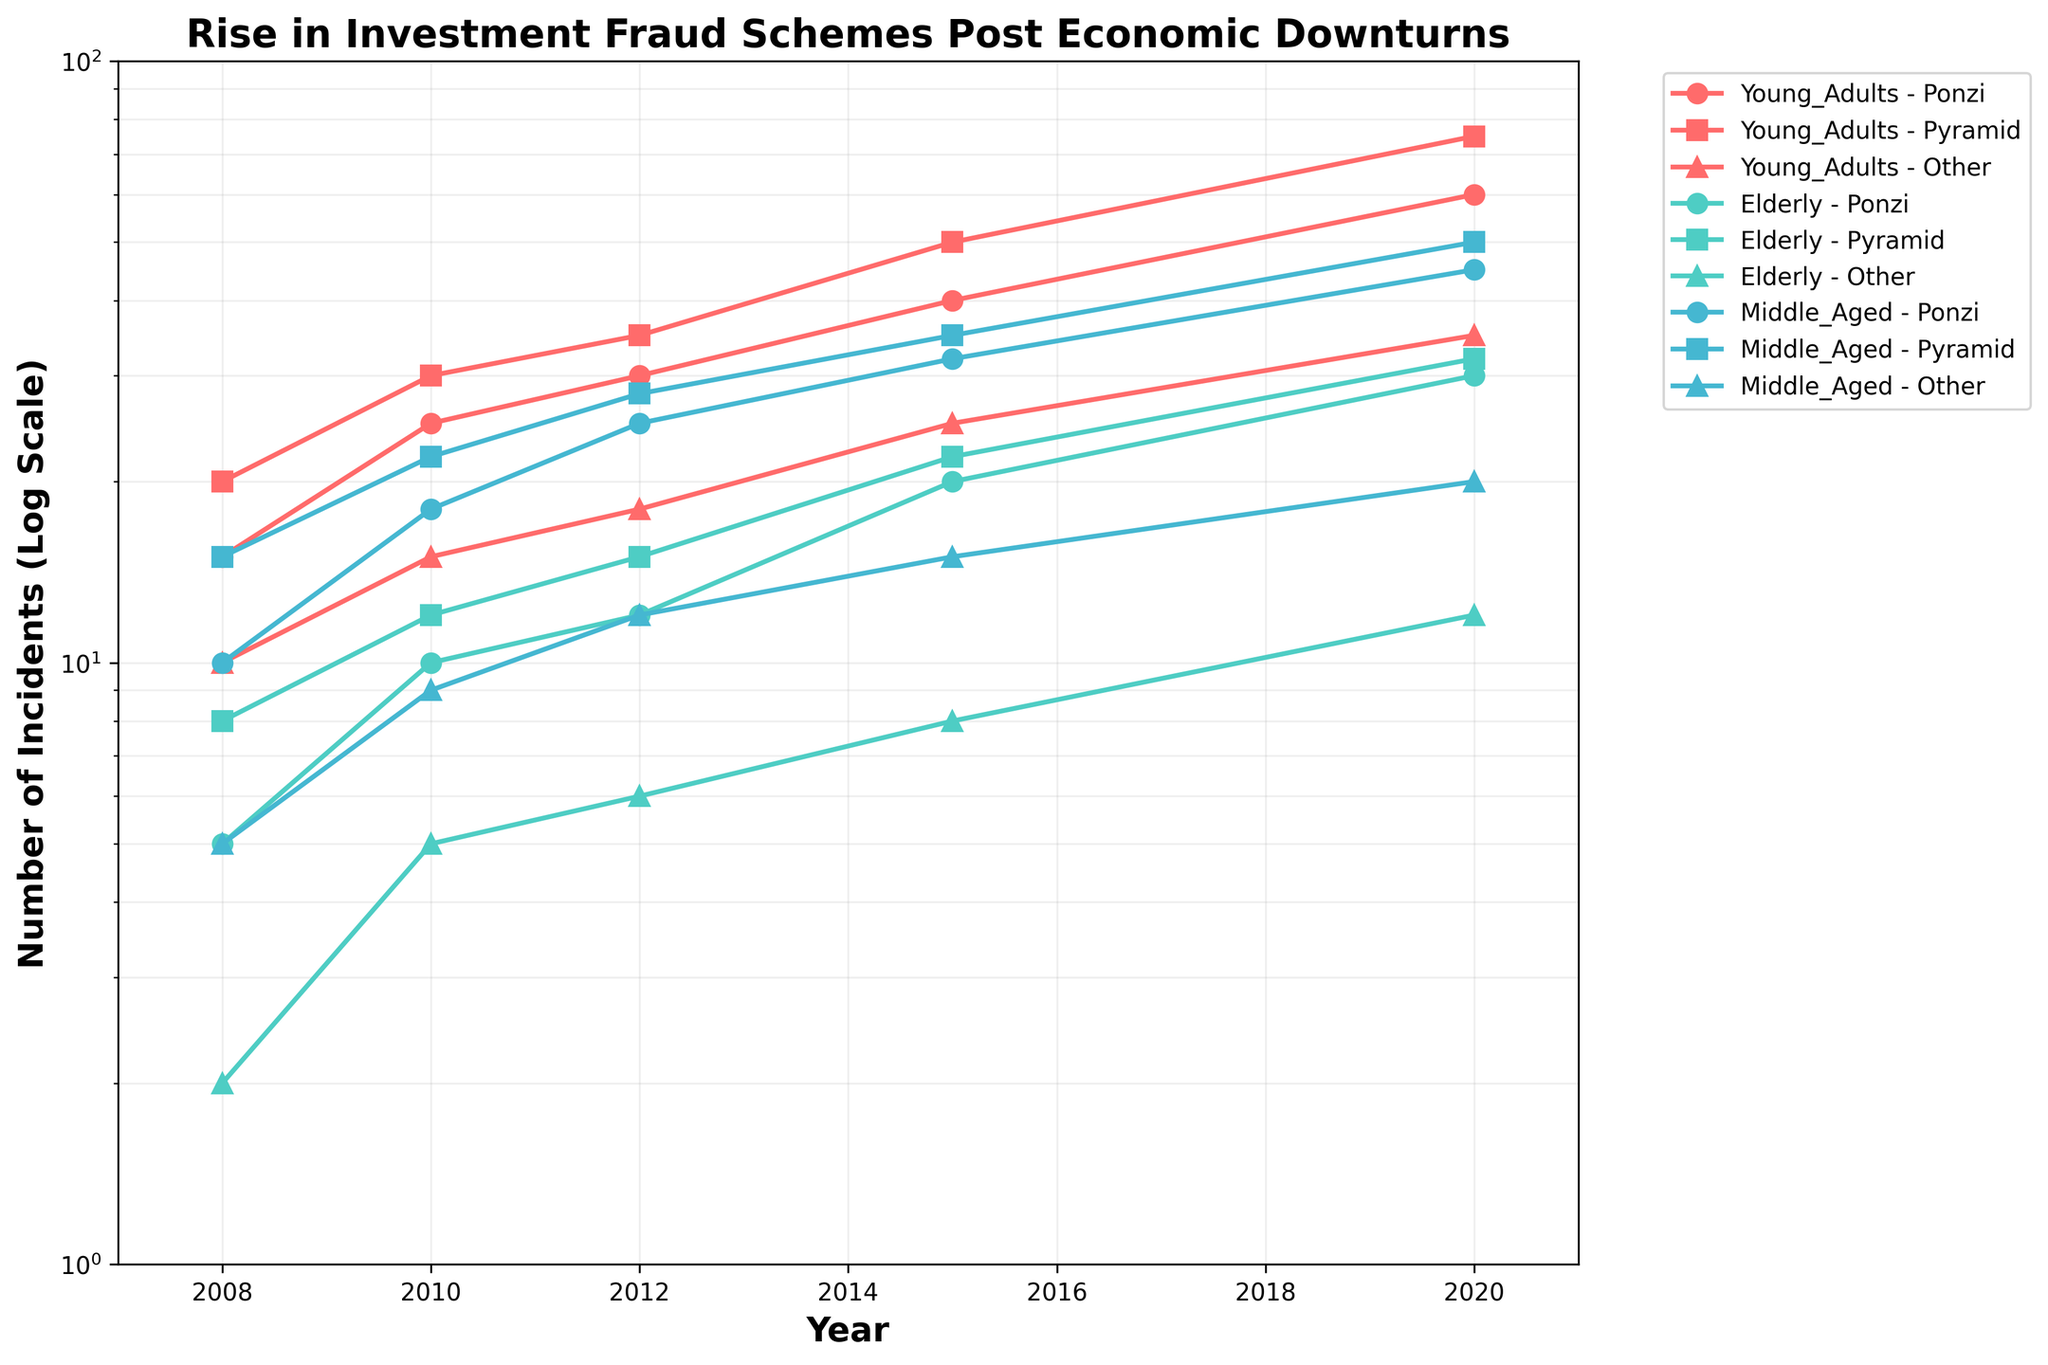What is the title of the plot? The title of the plot is displayed at the top center of the figure, providing an overview of the subject matter of the plot.
Answer: Rise in Investment Fraud Schemes Post Economic Downturns What are the colors used to represent the different demographic groups? The demographic groups are represented by distinct colors: Young Adults in red, Elderly in green, and Middle Aged in blue.
Answer: Red, Green, Blue Which demographic and type of scheme had the highest number of incidents in 2020? To answer this, look at the 2020 data points and identify which line reaches the highest point on the vertical axis for that year. The highest number is 75, corresponding to "Young Adults - Pyramid."
Answer: Young Adults - Pyramid What is the range of years displayed on the x-axis? The x-axis starts at the leftmost point and ends at the rightmost point, typically marked with the first and last years in the data range.
Answer: 2007 to 2021 How many incidents of Ponzi schemes were reported for the Elderly demographic in 2015? Locate the point in 2015 within the Elderly demographic line for Ponzi schemes and read the corresponding value.
Answer: 20 Which demographic saw the greatest increase in incidents of Ponzi schemes from 2008 to 2020? Calculate the difference between the 2020 and 2008 data points for each demographic group with respect to Ponzi schemes. Compare the differences to find the greatest increase. Young Adults increased by 60 - 15 = 45, Elderly by 30 - 5 = 25, and Middle Aged by 45 - 10 = 35. The greatest increase is in Young Adults.
Answer: Young Adults For the Middle_Aged demographic, how did the number of pyramid scheme incidents change from 2008 to 2010? Compare the number of incidents in 2008 and 2010 for the Middle_Aged demographic under Pyramid schemes. In 2008, it was 15, and in 2010, it was 22, so it increased by 7.
Answer: Increased by 7 Which type of scheme consistently had the lowest number of incidents across all demographics from 2008 to 2020? Observe the lines corresponding to each type of scheme across all demographics and note the values. "Other" schemes have consistently lower values compared to Ponzi and Pyramid schemes.
Answer: Other What is the trend in the number of incidents for Young Adults in Pyramid schemes between 2008 and 2020? Examine the line plot for Young Adults under Pyramid schemes from 2008 to 2020. The number of incidents steadily increases over this period.
Answer: Steady increase Compare the number of incidents for Ponzi schemes in 2012 between the Elderly and Middle_Aged demographics. Locate the 2012 data points for Ponzi schemes in both Elderly and Middle_Aged demographics and compare the values. For the Elderly, it's 12, and for Middle_Aged, it's 25, so Middle_Aged had more incidents.
Answer: Middle_Aged had more incidents 